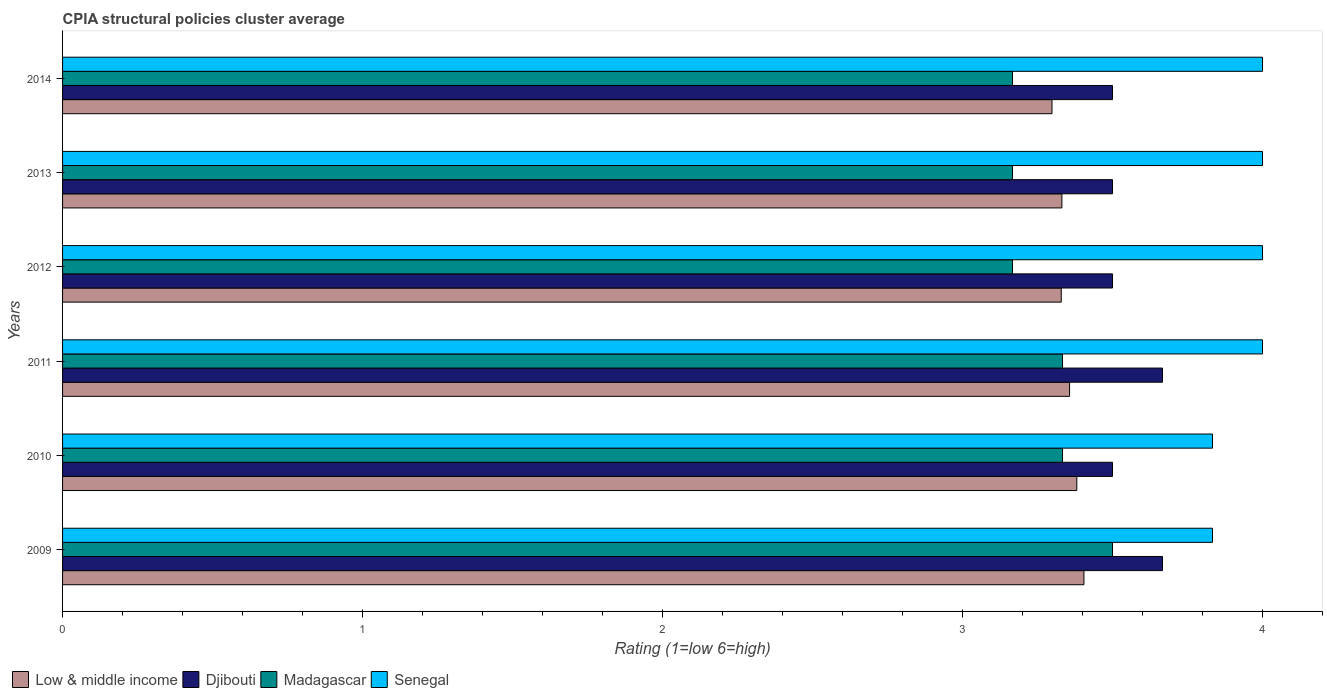How many different coloured bars are there?
Give a very brief answer. 4. How many groups of bars are there?
Make the answer very short. 6. Are the number of bars per tick equal to the number of legend labels?
Keep it short and to the point. Yes. In how many cases, is the number of bars for a given year not equal to the number of legend labels?
Keep it short and to the point. 0. What is the CPIA rating in Madagascar in 2011?
Provide a short and direct response. 3.33. Across all years, what is the maximum CPIA rating in Senegal?
Offer a terse response. 4. Across all years, what is the minimum CPIA rating in Senegal?
Make the answer very short. 3.83. What is the total CPIA rating in Madagascar in the graph?
Give a very brief answer. 19.67. What is the difference between the CPIA rating in Low & middle income in 2009 and that in 2013?
Your answer should be compact. 0.07. What is the difference between the CPIA rating in Senegal in 2014 and the CPIA rating in Low & middle income in 2012?
Offer a very short reply. 0.67. What is the average CPIA rating in Low & middle income per year?
Keep it short and to the point. 3.35. In the year 2011, what is the difference between the CPIA rating in Low & middle income and CPIA rating in Senegal?
Your answer should be very brief. -0.64. In how many years, is the CPIA rating in Senegal greater than 4 ?
Give a very brief answer. 0. What is the ratio of the CPIA rating in Low & middle income in 2009 to that in 2010?
Your answer should be very brief. 1.01. Is the CPIA rating in Low & middle income in 2010 less than that in 2013?
Ensure brevity in your answer.  No. Is the difference between the CPIA rating in Low & middle income in 2010 and 2012 greater than the difference between the CPIA rating in Senegal in 2010 and 2012?
Provide a short and direct response. Yes. What is the difference between the highest and the second highest CPIA rating in Madagascar?
Provide a succinct answer. 0.17. What is the difference between the highest and the lowest CPIA rating in Senegal?
Offer a terse response. 0.17. In how many years, is the CPIA rating in Low & middle income greater than the average CPIA rating in Low & middle income taken over all years?
Offer a terse response. 3. Is it the case that in every year, the sum of the CPIA rating in Djibouti and CPIA rating in Senegal is greater than the sum of CPIA rating in Madagascar and CPIA rating in Low & middle income?
Give a very brief answer. No. What does the 1st bar from the top in 2013 represents?
Ensure brevity in your answer.  Senegal. Is it the case that in every year, the sum of the CPIA rating in Low & middle income and CPIA rating in Senegal is greater than the CPIA rating in Djibouti?
Offer a very short reply. Yes. How many bars are there?
Offer a terse response. 24. Does the graph contain grids?
Make the answer very short. No. How are the legend labels stacked?
Make the answer very short. Horizontal. What is the title of the graph?
Your answer should be very brief. CPIA structural policies cluster average. Does "Sub-Saharan Africa (developing only)" appear as one of the legend labels in the graph?
Ensure brevity in your answer.  No. What is the label or title of the X-axis?
Offer a very short reply. Rating (1=low 6=high). What is the Rating (1=low 6=high) in Low & middle income in 2009?
Your answer should be very brief. 3.4. What is the Rating (1=low 6=high) in Djibouti in 2009?
Give a very brief answer. 3.67. What is the Rating (1=low 6=high) in Senegal in 2009?
Offer a very short reply. 3.83. What is the Rating (1=low 6=high) in Low & middle income in 2010?
Your answer should be very brief. 3.38. What is the Rating (1=low 6=high) of Djibouti in 2010?
Offer a very short reply. 3.5. What is the Rating (1=low 6=high) in Madagascar in 2010?
Make the answer very short. 3.33. What is the Rating (1=low 6=high) of Senegal in 2010?
Offer a very short reply. 3.83. What is the Rating (1=low 6=high) in Low & middle income in 2011?
Keep it short and to the point. 3.36. What is the Rating (1=low 6=high) in Djibouti in 2011?
Offer a very short reply. 3.67. What is the Rating (1=low 6=high) in Madagascar in 2011?
Ensure brevity in your answer.  3.33. What is the Rating (1=low 6=high) of Low & middle income in 2012?
Provide a short and direct response. 3.33. What is the Rating (1=low 6=high) of Djibouti in 2012?
Provide a short and direct response. 3.5. What is the Rating (1=low 6=high) of Madagascar in 2012?
Ensure brevity in your answer.  3.17. What is the Rating (1=low 6=high) of Low & middle income in 2013?
Your answer should be very brief. 3.33. What is the Rating (1=low 6=high) in Madagascar in 2013?
Your answer should be very brief. 3.17. What is the Rating (1=low 6=high) in Low & middle income in 2014?
Offer a terse response. 3.3. What is the Rating (1=low 6=high) in Madagascar in 2014?
Provide a short and direct response. 3.17. What is the Rating (1=low 6=high) in Senegal in 2014?
Provide a succinct answer. 4. Across all years, what is the maximum Rating (1=low 6=high) of Low & middle income?
Your answer should be very brief. 3.4. Across all years, what is the maximum Rating (1=low 6=high) of Djibouti?
Give a very brief answer. 3.67. Across all years, what is the maximum Rating (1=low 6=high) of Madagascar?
Offer a very short reply. 3.5. Across all years, what is the maximum Rating (1=low 6=high) of Senegal?
Offer a very short reply. 4. Across all years, what is the minimum Rating (1=low 6=high) in Low & middle income?
Give a very brief answer. 3.3. Across all years, what is the minimum Rating (1=low 6=high) in Madagascar?
Keep it short and to the point. 3.17. Across all years, what is the minimum Rating (1=low 6=high) in Senegal?
Ensure brevity in your answer.  3.83. What is the total Rating (1=low 6=high) in Low & middle income in the graph?
Keep it short and to the point. 20.1. What is the total Rating (1=low 6=high) in Djibouti in the graph?
Give a very brief answer. 21.33. What is the total Rating (1=low 6=high) of Madagascar in the graph?
Your answer should be very brief. 19.67. What is the total Rating (1=low 6=high) in Senegal in the graph?
Give a very brief answer. 23.67. What is the difference between the Rating (1=low 6=high) of Low & middle income in 2009 and that in 2010?
Make the answer very short. 0.02. What is the difference between the Rating (1=low 6=high) of Low & middle income in 2009 and that in 2011?
Give a very brief answer. 0.05. What is the difference between the Rating (1=low 6=high) of Djibouti in 2009 and that in 2011?
Provide a succinct answer. 0. What is the difference between the Rating (1=low 6=high) of Low & middle income in 2009 and that in 2012?
Your answer should be very brief. 0.08. What is the difference between the Rating (1=low 6=high) of Low & middle income in 2009 and that in 2013?
Your response must be concise. 0.07. What is the difference between the Rating (1=low 6=high) in Djibouti in 2009 and that in 2013?
Your response must be concise. 0.17. What is the difference between the Rating (1=low 6=high) of Low & middle income in 2009 and that in 2014?
Your answer should be compact. 0.11. What is the difference between the Rating (1=low 6=high) in Madagascar in 2009 and that in 2014?
Provide a succinct answer. 0.33. What is the difference between the Rating (1=low 6=high) in Senegal in 2009 and that in 2014?
Provide a succinct answer. -0.17. What is the difference between the Rating (1=low 6=high) of Low & middle income in 2010 and that in 2011?
Offer a very short reply. 0.02. What is the difference between the Rating (1=low 6=high) in Low & middle income in 2010 and that in 2012?
Make the answer very short. 0.05. What is the difference between the Rating (1=low 6=high) of Djibouti in 2010 and that in 2012?
Provide a succinct answer. 0. What is the difference between the Rating (1=low 6=high) in Madagascar in 2010 and that in 2012?
Your answer should be very brief. 0.17. What is the difference between the Rating (1=low 6=high) of Senegal in 2010 and that in 2012?
Provide a short and direct response. -0.17. What is the difference between the Rating (1=low 6=high) in Low & middle income in 2010 and that in 2013?
Give a very brief answer. 0.05. What is the difference between the Rating (1=low 6=high) in Djibouti in 2010 and that in 2013?
Your answer should be compact. 0. What is the difference between the Rating (1=low 6=high) in Madagascar in 2010 and that in 2013?
Offer a very short reply. 0.17. What is the difference between the Rating (1=low 6=high) in Senegal in 2010 and that in 2013?
Provide a succinct answer. -0.17. What is the difference between the Rating (1=low 6=high) in Low & middle income in 2010 and that in 2014?
Make the answer very short. 0.08. What is the difference between the Rating (1=low 6=high) of Low & middle income in 2011 and that in 2012?
Give a very brief answer. 0.03. What is the difference between the Rating (1=low 6=high) in Senegal in 2011 and that in 2012?
Make the answer very short. 0. What is the difference between the Rating (1=low 6=high) in Low & middle income in 2011 and that in 2013?
Ensure brevity in your answer.  0.03. What is the difference between the Rating (1=low 6=high) in Madagascar in 2011 and that in 2013?
Give a very brief answer. 0.17. What is the difference between the Rating (1=low 6=high) in Senegal in 2011 and that in 2013?
Your response must be concise. 0. What is the difference between the Rating (1=low 6=high) in Low & middle income in 2011 and that in 2014?
Your answer should be very brief. 0.06. What is the difference between the Rating (1=low 6=high) in Madagascar in 2011 and that in 2014?
Offer a terse response. 0.17. What is the difference between the Rating (1=low 6=high) in Low & middle income in 2012 and that in 2013?
Keep it short and to the point. -0. What is the difference between the Rating (1=low 6=high) of Djibouti in 2012 and that in 2013?
Your answer should be compact. 0. What is the difference between the Rating (1=low 6=high) in Senegal in 2012 and that in 2013?
Your response must be concise. 0. What is the difference between the Rating (1=low 6=high) in Low & middle income in 2012 and that in 2014?
Provide a succinct answer. 0.03. What is the difference between the Rating (1=low 6=high) of Djibouti in 2012 and that in 2014?
Ensure brevity in your answer.  0. What is the difference between the Rating (1=low 6=high) of Low & middle income in 2013 and that in 2014?
Offer a very short reply. 0.03. What is the difference between the Rating (1=low 6=high) in Djibouti in 2013 and that in 2014?
Your answer should be very brief. 0. What is the difference between the Rating (1=low 6=high) of Senegal in 2013 and that in 2014?
Your response must be concise. 0. What is the difference between the Rating (1=low 6=high) in Low & middle income in 2009 and the Rating (1=low 6=high) in Djibouti in 2010?
Provide a succinct answer. -0.1. What is the difference between the Rating (1=low 6=high) in Low & middle income in 2009 and the Rating (1=low 6=high) in Madagascar in 2010?
Offer a very short reply. 0.07. What is the difference between the Rating (1=low 6=high) of Low & middle income in 2009 and the Rating (1=low 6=high) of Senegal in 2010?
Provide a short and direct response. -0.43. What is the difference between the Rating (1=low 6=high) in Djibouti in 2009 and the Rating (1=low 6=high) in Madagascar in 2010?
Keep it short and to the point. 0.33. What is the difference between the Rating (1=low 6=high) in Madagascar in 2009 and the Rating (1=low 6=high) in Senegal in 2010?
Make the answer very short. -0.33. What is the difference between the Rating (1=low 6=high) in Low & middle income in 2009 and the Rating (1=low 6=high) in Djibouti in 2011?
Offer a very short reply. -0.26. What is the difference between the Rating (1=low 6=high) in Low & middle income in 2009 and the Rating (1=low 6=high) in Madagascar in 2011?
Provide a short and direct response. 0.07. What is the difference between the Rating (1=low 6=high) in Low & middle income in 2009 and the Rating (1=low 6=high) in Senegal in 2011?
Your answer should be very brief. -0.6. What is the difference between the Rating (1=low 6=high) of Djibouti in 2009 and the Rating (1=low 6=high) of Madagascar in 2011?
Make the answer very short. 0.33. What is the difference between the Rating (1=low 6=high) of Djibouti in 2009 and the Rating (1=low 6=high) of Senegal in 2011?
Ensure brevity in your answer.  -0.33. What is the difference between the Rating (1=low 6=high) in Low & middle income in 2009 and the Rating (1=low 6=high) in Djibouti in 2012?
Your answer should be compact. -0.1. What is the difference between the Rating (1=low 6=high) in Low & middle income in 2009 and the Rating (1=low 6=high) in Madagascar in 2012?
Offer a terse response. 0.24. What is the difference between the Rating (1=low 6=high) in Low & middle income in 2009 and the Rating (1=low 6=high) in Senegal in 2012?
Ensure brevity in your answer.  -0.6. What is the difference between the Rating (1=low 6=high) of Djibouti in 2009 and the Rating (1=low 6=high) of Senegal in 2012?
Offer a very short reply. -0.33. What is the difference between the Rating (1=low 6=high) of Low & middle income in 2009 and the Rating (1=low 6=high) of Djibouti in 2013?
Give a very brief answer. -0.1. What is the difference between the Rating (1=low 6=high) of Low & middle income in 2009 and the Rating (1=low 6=high) of Madagascar in 2013?
Make the answer very short. 0.24. What is the difference between the Rating (1=low 6=high) in Low & middle income in 2009 and the Rating (1=low 6=high) in Senegal in 2013?
Provide a short and direct response. -0.6. What is the difference between the Rating (1=low 6=high) of Low & middle income in 2009 and the Rating (1=low 6=high) of Djibouti in 2014?
Offer a very short reply. -0.1. What is the difference between the Rating (1=low 6=high) in Low & middle income in 2009 and the Rating (1=low 6=high) in Madagascar in 2014?
Provide a short and direct response. 0.24. What is the difference between the Rating (1=low 6=high) in Low & middle income in 2009 and the Rating (1=low 6=high) in Senegal in 2014?
Keep it short and to the point. -0.6. What is the difference between the Rating (1=low 6=high) in Djibouti in 2009 and the Rating (1=low 6=high) in Senegal in 2014?
Your answer should be very brief. -0.33. What is the difference between the Rating (1=low 6=high) in Madagascar in 2009 and the Rating (1=low 6=high) in Senegal in 2014?
Your answer should be compact. -0.5. What is the difference between the Rating (1=low 6=high) of Low & middle income in 2010 and the Rating (1=low 6=high) of Djibouti in 2011?
Make the answer very short. -0.29. What is the difference between the Rating (1=low 6=high) of Low & middle income in 2010 and the Rating (1=low 6=high) of Madagascar in 2011?
Keep it short and to the point. 0.05. What is the difference between the Rating (1=low 6=high) of Low & middle income in 2010 and the Rating (1=low 6=high) of Senegal in 2011?
Ensure brevity in your answer.  -0.62. What is the difference between the Rating (1=low 6=high) of Madagascar in 2010 and the Rating (1=low 6=high) of Senegal in 2011?
Provide a succinct answer. -0.67. What is the difference between the Rating (1=low 6=high) of Low & middle income in 2010 and the Rating (1=low 6=high) of Djibouti in 2012?
Provide a short and direct response. -0.12. What is the difference between the Rating (1=low 6=high) in Low & middle income in 2010 and the Rating (1=low 6=high) in Madagascar in 2012?
Ensure brevity in your answer.  0.21. What is the difference between the Rating (1=low 6=high) of Low & middle income in 2010 and the Rating (1=low 6=high) of Senegal in 2012?
Give a very brief answer. -0.62. What is the difference between the Rating (1=low 6=high) in Djibouti in 2010 and the Rating (1=low 6=high) in Senegal in 2012?
Provide a succinct answer. -0.5. What is the difference between the Rating (1=low 6=high) of Madagascar in 2010 and the Rating (1=low 6=high) of Senegal in 2012?
Your answer should be compact. -0.67. What is the difference between the Rating (1=low 6=high) in Low & middle income in 2010 and the Rating (1=low 6=high) in Djibouti in 2013?
Give a very brief answer. -0.12. What is the difference between the Rating (1=low 6=high) of Low & middle income in 2010 and the Rating (1=low 6=high) of Madagascar in 2013?
Your answer should be compact. 0.21. What is the difference between the Rating (1=low 6=high) of Low & middle income in 2010 and the Rating (1=low 6=high) of Senegal in 2013?
Give a very brief answer. -0.62. What is the difference between the Rating (1=low 6=high) of Low & middle income in 2010 and the Rating (1=low 6=high) of Djibouti in 2014?
Your answer should be compact. -0.12. What is the difference between the Rating (1=low 6=high) of Low & middle income in 2010 and the Rating (1=low 6=high) of Madagascar in 2014?
Offer a terse response. 0.21. What is the difference between the Rating (1=low 6=high) in Low & middle income in 2010 and the Rating (1=low 6=high) in Senegal in 2014?
Offer a very short reply. -0.62. What is the difference between the Rating (1=low 6=high) in Djibouti in 2010 and the Rating (1=low 6=high) in Madagascar in 2014?
Provide a succinct answer. 0.33. What is the difference between the Rating (1=low 6=high) in Djibouti in 2010 and the Rating (1=low 6=high) in Senegal in 2014?
Your answer should be very brief. -0.5. What is the difference between the Rating (1=low 6=high) in Low & middle income in 2011 and the Rating (1=low 6=high) in Djibouti in 2012?
Your response must be concise. -0.14. What is the difference between the Rating (1=low 6=high) of Low & middle income in 2011 and the Rating (1=low 6=high) of Madagascar in 2012?
Offer a very short reply. 0.19. What is the difference between the Rating (1=low 6=high) in Low & middle income in 2011 and the Rating (1=low 6=high) in Senegal in 2012?
Make the answer very short. -0.64. What is the difference between the Rating (1=low 6=high) in Djibouti in 2011 and the Rating (1=low 6=high) in Madagascar in 2012?
Make the answer very short. 0.5. What is the difference between the Rating (1=low 6=high) of Djibouti in 2011 and the Rating (1=low 6=high) of Senegal in 2012?
Your answer should be very brief. -0.33. What is the difference between the Rating (1=low 6=high) of Low & middle income in 2011 and the Rating (1=low 6=high) of Djibouti in 2013?
Your response must be concise. -0.14. What is the difference between the Rating (1=low 6=high) in Low & middle income in 2011 and the Rating (1=low 6=high) in Madagascar in 2013?
Offer a very short reply. 0.19. What is the difference between the Rating (1=low 6=high) in Low & middle income in 2011 and the Rating (1=low 6=high) in Senegal in 2013?
Ensure brevity in your answer.  -0.64. What is the difference between the Rating (1=low 6=high) of Djibouti in 2011 and the Rating (1=low 6=high) of Madagascar in 2013?
Make the answer very short. 0.5. What is the difference between the Rating (1=low 6=high) of Madagascar in 2011 and the Rating (1=low 6=high) of Senegal in 2013?
Your answer should be compact. -0.67. What is the difference between the Rating (1=low 6=high) in Low & middle income in 2011 and the Rating (1=low 6=high) in Djibouti in 2014?
Ensure brevity in your answer.  -0.14. What is the difference between the Rating (1=low 6=high) of Low & middle income in 2011 and the Rating (1=low 6=high) of Madagascar in 2014?
Make the answer very short. 0.19. What is the difference between the Rating (1=low 6=high) of Low & middle income in 2011 and the Rating (1=low 6=high) of Senegal in 2014?
Your response must be concise. -0.64. What is the difference between the Rating (1=low 6=high) of Djibouti in 2011 and the Rating (1=low 6=high) of Senegal in 2014?
Your answer should be compact. -0.33. What is the difference between the Rating (1=low 6=high) of Low & middle income in 2012 and the Rating (1=low 6=high) of Djibouti in 2013?
Keep it short and to the point. -0.17. What is the difference between the Rating (1=low 6=high) of Low & middle income in 2012 and the Rating (1=low 6=high) of Madagascar in 2013?
Provide a succinct answer. 0.16. What is the difference between the Rating (1=low 6=high) of Low & middle income in 2012 and the Rating (1=low 6=high) of Senegal in 2013?
Your answer should be compact. -0.67. What is the difference between the Rating (1=low 6=high) in Low & middle income in 2012 and the Rating (1=low 6=high) in Djibouti in 2014?
Make the answer very short. -0.17. What is the difference between the Rating (1=low 6=high) in Low & middle income in 2012 and the Rating (1=low 6=high) in Madagascar in 2014?
Offer a very short reply. 0.16. What is the difference between the Rating (1=low 6=high) of Low & middle income in 2012 and the Rating (1=low 6=high) of Senegal in 2014?
Provide a short and direct response. -0.67. What is the difference between the Rating (1=low 6=high) in Djibouti in 2012 and the Rating (1=low 6=high) in Senegal in 2014?
Offer a terse response. -0.5. What is the difference between the Rating (1=low 6=high) in Madagascar in 2012 and the Rating (1=low 6=high) in Senegal in 2014?
Provide a succinct answer. -0.83. What is the difference between the Rating (1=low 6=high) of Low & middle income in 2013 and the Rating (1=low 6=high) of Djibouti in 2014?
Provide a short and direct response. -0.17. What is the difference between the Rating (1=low 6=high) of Low & middle income in 2013 and the Rating (1=low 6=high) of Madagascar in 2014?
Your response must be concise. 0.16. What is the difference between the Rating (1=low 6=high) of Low & middle income in 2013 and the Rating (1=low 6=high) of Senegal in 2014?
Ensure brevity in your answer.  -0.67. What is the difference between the Rating (1=low 6=high) in Djibouti in 2013 and the Rating (1=low 6=high) in Madagascar in 2014?
Offer a terse response. 0.33. What is the difference between the Rating (1=low 6=high) of Djibouti in 2013 and the Rating (1=low 6=high) of Senegal in 2014?
Ensure brevity in your answer.  -0.5. What is the average Rating (1=low 6=high) in Low & middle income per year?
Provide a succinct answer. 3.35. What is the average Rating (1=low 6=high) in Djibouti per year?
Provide a succinct answer. 3.56. What is the average Rating (1=low 6=high) of Madagascar per year?
Make the answer very short. 3.28. What is the average Rating (1=low 6=high) of Senegal per year?
Your response must be concise. 3.94. In the year 2009, what is the difference between the Rating (1=low 6=high) of Low & middle income and Rating (1=low 6=high) of Djibouti?
Give a very brief answer. -0.26. In the year 2009, what is the difference between the Rating (1=low 6=high) of Low & middle income and Rating (1=low 6=high) of Madagascar?
Offer a very short reply. -0.1. In the year 2009, what is the difference between the Rating (1=low 6=high) of Low & middle income and Rating (1=low 6=high) of Senegal?
Make the answer very short. -0.43. In the year 2009, what is the difference between the Rating (1=low 6=high) in Djibouti and Rating (1=low 6=high) in Senegal?
Ensure brevity in your answer.  -0.17. In the year 2010, what is the difference between the Rating (1=low 6=high) in Low & middle income and Rating (1=low 6=high) in Djibouti?
Provide a succinct answer. -0.12. In the year 2010, what is the difference between the Rating (1=low 6=high) of Low & middle income and Rating (1=low 6=high) of Madagascar?
Provide a short and direct response. 0.05. In the year 2010, what is the difference between the Rating (1=low 6=high) in Low & middle income and Rating (1=low 6=high) in Senegal?
Your response must be concise. -0.45. In the year 2010, what is the difference between the Rating (1=low 6=high) of Djibouti and Rating (1=low 6=high) of Madagascar?
Offer a very short reply. 0.17. In the year 2010, what is the difference between the Rating (1=low 6=high) in Djibouti and Rating (1=low 6=high) in Senegal?
Your answer should be compact. -0.33. In the year 2010, what is the difference between the Rating (1=low 6=high) in Madagascar and Rating (1=low 6=high) in Senegal?
Your answer should be very brief. -0.5. In the year 2011, what is the difference between the Rating (1=low 6=high) of Low & middle income and Rating (1=low 6=high) of Djibouti?
Your answer should be very brief. -0.31. In the year 2011, what is the difference between the Rating (1=low 6=high) in Low & middle income and Rating (1=low 6=high) in Madagascar?
Offer a very short reply. 0.02. In the year 2011, what is the difference between the Rating (1=low 6=high) of Low & middle income and Rating (1=low 6=high) of Senegal?
Your answer should be very brief. -0.64. In the year 2011, what is the difference between the Rating (1=low 6=high) in Djibouti and Rating (1=low 6=high) in Madagascar?
Your response must be concise. 0.33. In the year 2011, what is the difference between the Rating (1=low 6=high) of Madagascar and Rating (1=low 6=high) of Senegal?
Your answer should be very brief. -0.67. In the year 2012, what is the difference between the Rating (1=low 6=high) of Low & middle income and Rating (1=low 6=high) of Djibouti?
Ensure brevity in your answer.  -0.17. In the year 2012, what is the difference between the Rating (1=low 6=high) of Low & middle income and Rating (1=low 6=high) of Madagascar?
Make the answer very short. 0.16. In the year 2012, what is the difference between the Rating (1=low 6=high) in Low & middle income and Rating (1=low 6=high) in Senegal?
Make the answer very short. -0.67. In the year 2013, what is the difference between the Rating (1=low 6=high) of Low & middle income and Rating (1=low 6=high) of Djibouti?
Offer a very short reply. -0.17. In the year 2013, what is the difference between the Rating (1=low 6=high) in Low & middle income and Rating (1=low 6=high) in Madagascar?
Give a very brief answer. 0.16. In the year 2013, what is the difference between the Rating (1=low 6=high) in Low & middle income and Rating (1=low 6=high) in Senegal?
Provide a short and direct response. -0.67. In the year 2013, what is the difference between the Rating (1=low 6=high) in Djibouti and Rating (1=low 6=high) in Madagascar?
Your answer should be compact. 0.33. In the year 2014, what is the difference between the Rating (1=low 6=high) of Low & middle income and Rating (1=low 6=high) of Djibouti?
Provide a short and direct response. -0.2. In the year 2014, what is the difference between the Rating (1=low 6=high) of Low & middle income and Rating (1=low 6=high) of Madagascar?
Ensure brevity in your answer.  0.13. In the year 2014, what is the difference between the Rating (1=low 6=high) of Low & middle income and Rating (1=low 6=high) of Senegal?
Provide a succinct answer. -0.7. In the year 2014, what is the difference between the Rating (1=low 6=high) of Djibouti and Rating (1=low 6=high) of Madagascar?
Ensure brevity in your answer.  0.33. In the year 2014, what is the difference between the Rating (1=low 6=high) in Djibouti and Rating (1=low 6=high) in Senegal?
Offer a very short reply. -0.5. In the year 2014, what is the difference between the Rating (1=low 6=high) of Madagascar and Rating (1=low 6=high) of Senegal?
Provide a succinct answer. -0.83. What is the ratio of the Rating (1=low 6=high) in Djibouti in 2009 to that in 2010?
Offer a terse response. 1.05. What is the ratio of the Rating (1=low 6=high) of Madagascar in 2009 to that in 2010?
Your answer should be very brief. 1.05. What is the ratio of the Rating (1=low 6=high) in Senegal in 2009 to that in 2010?
Provide a succinct answer. 1. What is the ratio of the Rating (1=low 6=high) of Low & middle income in 2009 to that in 2011?
Give a very brief answer. 1.01. What is the ratio of the Rating (1=low 6=high) in Djibouti in 2009 to that in 2011?
Your answer should be compact. 1. What is the ratio of the Rating (1=low 6=high) in Madagascar in 2009 to that in 2011?
Your answer should be very brief. 1.05. What is the ratio of the Rating (1=low 6=high) of Senegal in 2009 to that in 2011?
Offer a terse response. 0.96. What is the ratio of the Rating (1=low 6=high) of Low & middle income in 2009 to that in 2012?
Offer a very short reply. 1.02. What is the ratio of the Rating (1=low 6=high) of Djibouti in 2009 to that in 2012?
Keep it short and to the point. 1.05. What is the ratio of the Rating (1=low 6=high) in Madagascar in 2009 to that in 2012?
Provide a succinct answer. 1.11. What is the ratio of the Rating (1=low 6=high) in Low & middle income in 2009 to that in 2013?
Your response must be concise. 1.02. What is the ratio of the Rating (1=low 6=high) in Djibouti in 2009 to that in 2013?
Keep it short and to the point. 1.05. What is the ratio of the Rating (1=low 6=high) of Madagascar in 2009 to that in 2013?
Offer a very short reply. 1.11. What is the ratio of the Rating (1=low 6=high) in Senegal in 2009 to that in 2013?
Provide a short and direct response. 0.96. What is the ratio of the Rating (1=low 6=high) of Low & middle income in 2009 to that in 2014?
Make the answer very short. 1.03. What is the ratio of the Rating (1=low 6=high) in Djibouti in 2009 to that in 2014?
Ensure brevity in your answer.  1.05. What is the ratio of the Rating (1=low 6=high) in Madagascar in 2009 to that in 2014?
Your answer should be compact. 1.11. What is the ratio of the Rating (1=low 6=high) in Senegal in 2009 to that in 2014?
Your answer should be compact. 0.96. What is the ratio of the Rating (1=low 6=high) in Low & middle income in 2010 to that in 2011?
Make the answer very short. 1.01. What is the ratio of the Rating (1=low 6=high) of Djibouti in 2010 to that in 2011?
Offer a terse response. 0.95. What is the ratio of the Rating (1=low 6=high) in Senegal in 2010 to that in 2011?
Provide a short and direct response. 0.96. What is the ratio of the Rating (1=low 6=high) of Low & middle income in 2010 to that in 2012?
Provide a succinct answer. 1.02. What is the ratio of the Rating (1=low 6=high) of Madagascar in 2010 to that in 2012?
Your answer should be very brief. 1.05. What is the ratio of the Rating (1=low 6=high) of Low & middle income in 2010 to that in 2013?
Keep it short and to the point. 1.01. What is the ratio of the Rating (1=low 6=high) in Djibouti in 2010 to that in 2013?
Offer a very short reply. 1. What is the ratio of the Rating (1=low 6=high) of Madagascar in 2010 to that in 2013?
Your answer should be compact. 1.05. What is the ratio of the Rating (1=low 6=high) in Senegal in 2010 to that in 2013?
Your answer should be compact. 0.96. What is the ratio of the Rating (1=low 6=high) in Low & middle income in 2010 to that in 2014?
Your answer should be very brief. 1.03. What is the ratio of the Rating (1=low 6=high) in Djibouti in 2010 to that in 2014?
Your response must be concise. 1. What is the ratio of the Rating (1=low 6=high) in Madagascar in 2010 to that in 2014?
Provide a short and direct response. 1.05. What is the ratio of the Rating (1=low 6=high) in Low & middle income in 2011 to that in 2012?
Your response must be concise. 1.01. What is the ratio of the Rating (1=low 6=high) in Djibouti in 2011 to that in 2012?
Your answer should be compact. 1.05. What is the ratio of the Rating (1=low 6=high) of Madagascar in 2011 to that in 2012?
Give a very brief answer. 1.05. What is the ratio of the Rating (1=low 6=high) in Low & middle income in 2011 to that in 2013?
Ensure brevity in your answer.  1.01. What is the ratio of the Rating (1=low 6=high) of Djibouti in 2011 to that in 2013?
Keep it short and to the point. 1.05. What is the ratio of the Rating (1=low 6=high) in Madagascar in 2011 to that in 2013?
Your response must be concise. 1.05. What is the ratio of the Rating (1=low 6=high) in Low & middle income in 2011 to that in 2014?
Keep it short and to the point. 1.02. What is the ratio of the Rating (1=low 6=high) in Djibouti in 2011 to that in 2014?
Ensure brevity in your answer.  1.05. What is the ratio of the Rating (1=low 6=high) of Madagascar in 2011 to that in 2014?
Ensure brevity in your answer.  1.05. What is the ratio of the Rating (1=low 6=high) of Djibouti in 2012 to that in 2013?
Provide a succinct answer. 1. What is the ratio of the Rating (1=low 6=high) in Madagascar in 2012 to that in 2013?
Ensure brevity in your answer.  1. What is the ratio of the Rating (1=low 6=high) in Low & middle income in 2012 to that in 2014?
Offer a very short reply. 1.01. What is the ratio of the Rating (1=low 6=high) of Madagascar in 2012 to that in 2014?
Provide a succinct answer. 1. What is the ratio of the Rating (1=low 6=high) in Low & middle income in 2013 to that in 2014?
Give a very brief answer. 1.01. What is the ratio of the Rating (1=low 6=high) in Madagascar in 2013 to that in 2014?
Your answer should be very brief. 1. What is the difference between the highest and the second highest Rating (1=low 6=high) in Low & middle income?
Keep it short and to the point. 0.02. What is the difference between the highest and the lowest Rating (1=low 6=high) of Low & middle income?
Give a very brief answer. 0.11. What is the difference between the highest and the lowest Rating (1=low 6=high) in Madagascar?
Provide a short and direct response. 0.33. What is the difference between the highest and the lowest Rating (1=low 6=high) of Senegal?
Your answer should be very brief. 0.17. 